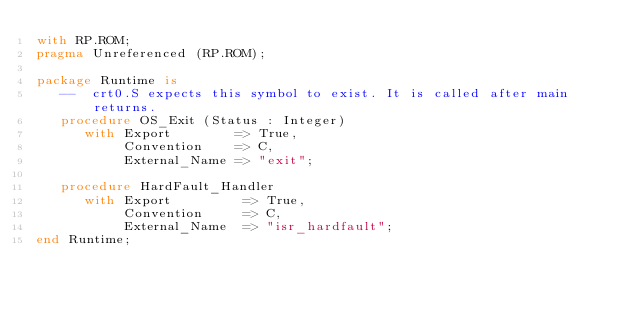Convert code to text. <code><loc_0><loc_0><loc_500><loc_500><_Ada_>with RP.ROM;
pragma Unreferenced (RP.ROM);

package Runtime is
   --  crt0.S expects this symbol to exist. It is called after main returns.
   procedure OS_Exit (Status : Integer)
      with Export        => True,
           Convention    => C,
           External_Name => "exit";

   procedure HardFault_Handler
      with Export         => True,
           Convention     => C,
           External_Name  => "isr_hardfault";
end Runtime;
</code> 